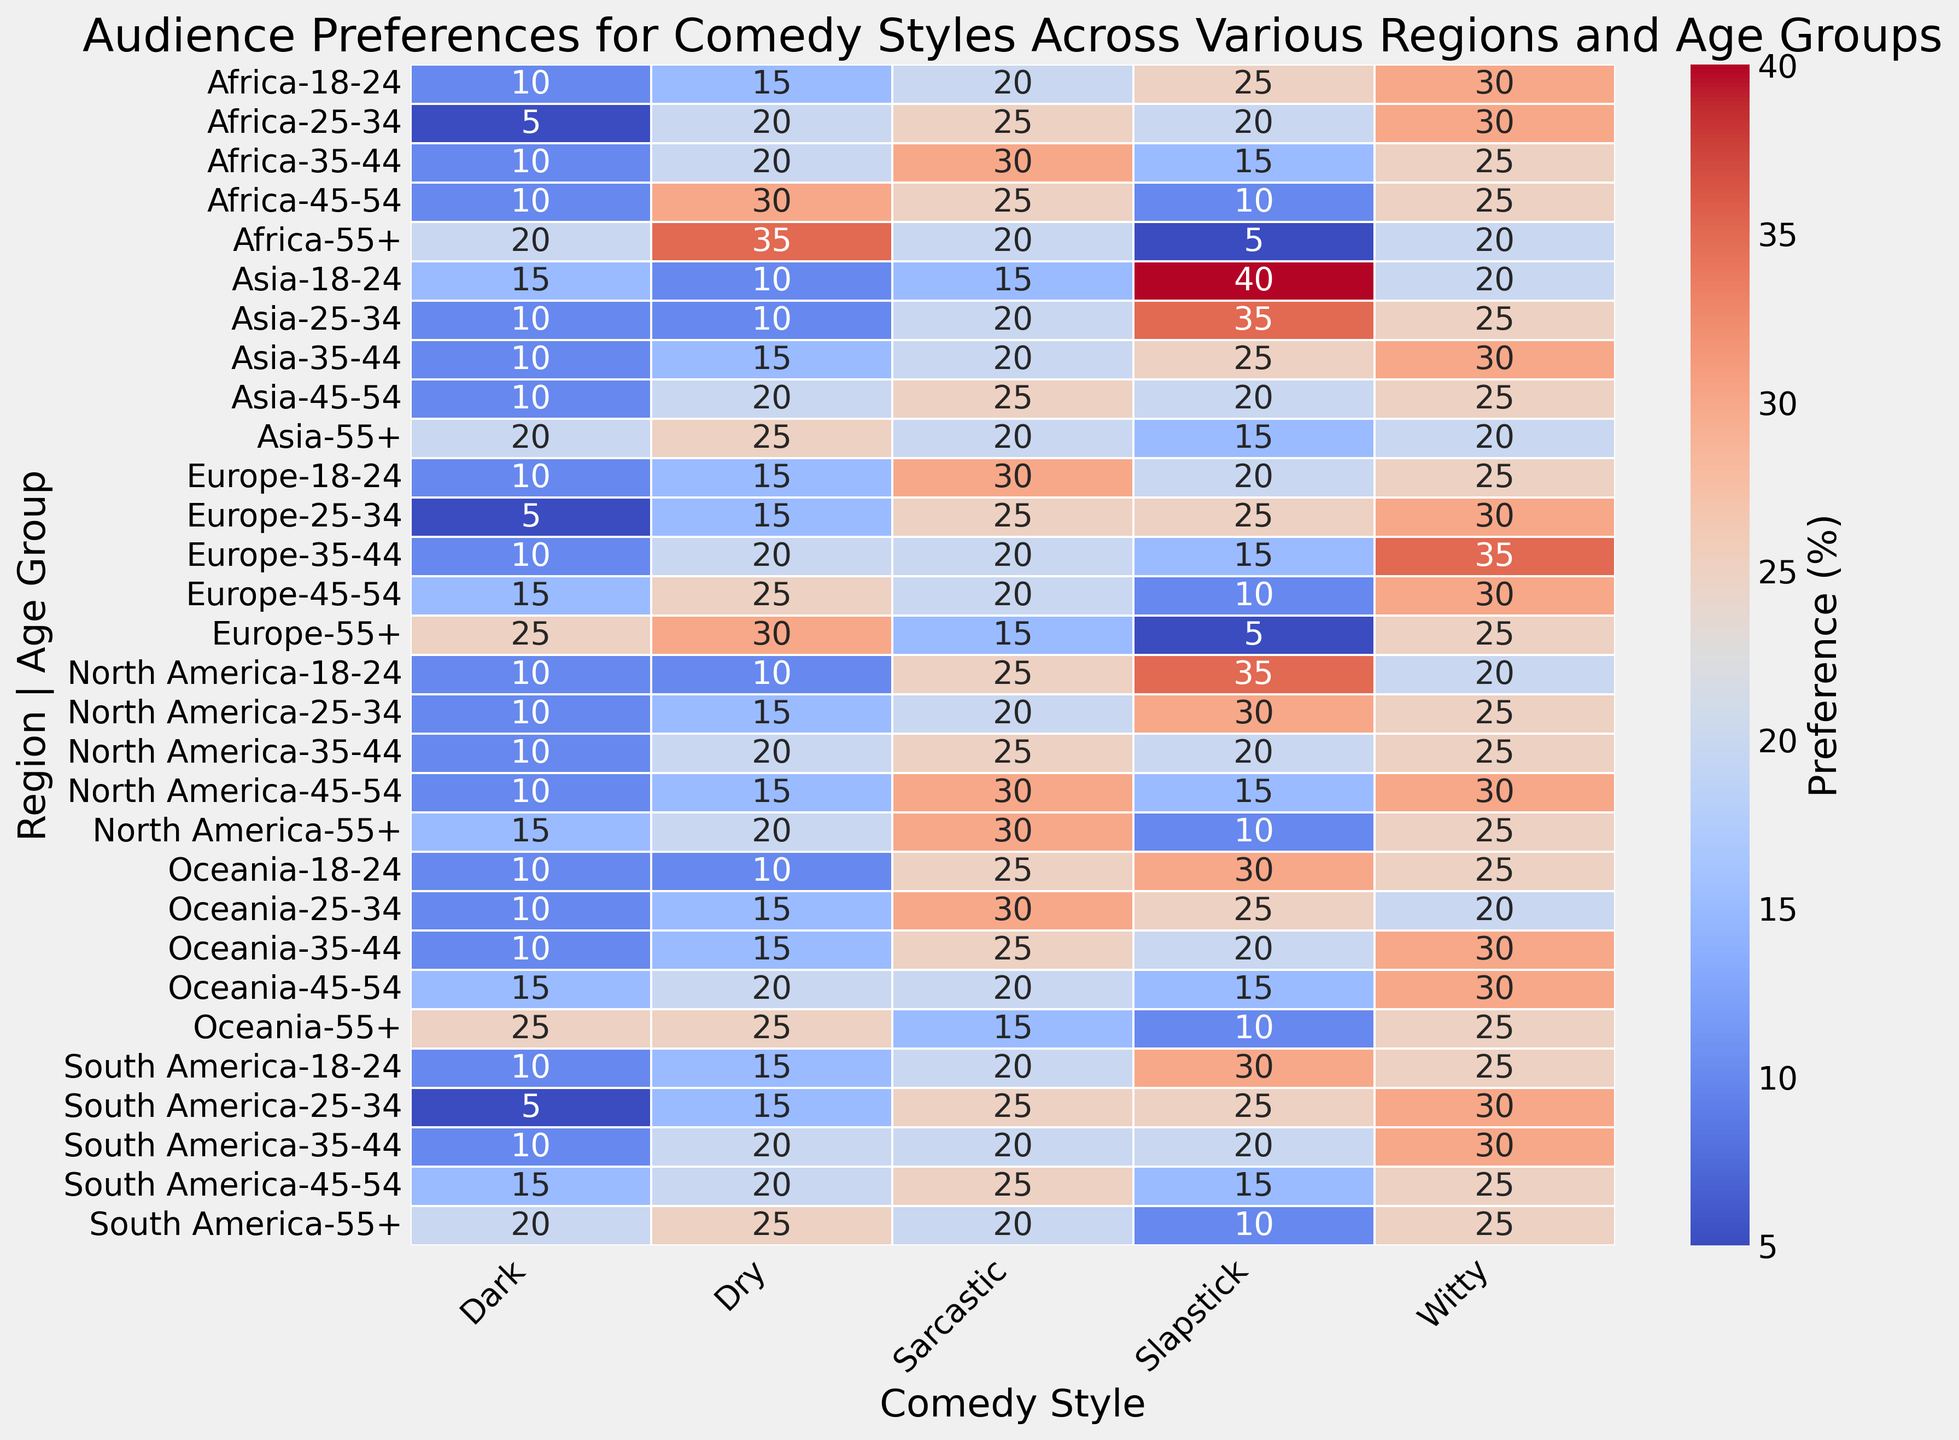Which region and age group prefers slapstick comedy the most? By observing the heatmap, scan for the cell with the highest percentage in the 'Slapstick' column and check the corresponding region and age group.
Answer: Asia, 18-24 Which comedy style is least preferred by the 55+ age group in Europe? Look at the row for Europe, 55+ group and identify the cell with the smallest value across all comedy styles.
Answer: Slapstick Compare the preference for witty comedy between North America (18-24) and Africa (18-24). Which group prefers witty comedy more, and by how much? Locate the cells for witty comedy in North America, 18-24 (value: 20) and Africa, 18-24 (value: 30). Subtract the smaller value from the larger one to find the difference.
Answer: Africa, by 10% What is the average preference for dry comedy in the 25-34 age group across all regions? Extract the percentages for dry comedy in the 25-34 age group for all regions: (North America: 15, Europe: 15, Asia: 10, South America: 15, Africa: 20, Oceania: 15). Calculate the average by summing these values and dividing by the total number of regions. (15 + 15 + 10 + 15 + 20 + 15) / 6 = 15
Answer: 15 How does the preference for dark comedy change with age in South America? Track the values for dark comedy across the age groups in South America: (18-24: 10, 25-34: 5, 35-44: 10, 45-54: 15, 55+: 20). Note the increasing or decreasing trend. The values increase from 10 in the 18-24 group to 20 in the 55+ group.
Answer: It increases Which combination of region and age group has the least total preference for all comedy styles combined? Sum the percentages across all comedy styles for each region and age group. Identify the combination with the smallest sum. For example, Africa, 55+: (5 + 20 + 20 + 35 + 20) = 100.
Answer: Europe, 55+ Based on the visual qualities, which region and age group has the darkest shade in the sarcastic comedy column and what does this signify? The darkest shade indicates the highest value in the sarcastic comedy column. Locate the deepest red shade in the sarcastic column and identify the associated region and age group.
Answer: North America, 55+ signifies 30% preference Calculate the total preference for all comedy styles for the 45-54 age group in Oceania. Add the percentages for all comedy styles for Oceania, 45-54: (15 + 20 + 30 + 20 + 15). (15 + 20 + 30 + 20 + 15) = 100
Answer: 100 In which region do younger audiences (18-24) prefer sarcastic comedy significantly more than older audiences (55+), and by how much? Compare the values of sarcastic comedy for 18-24 and 55+ age groups in each region. Calculate the difference and identify the region where this difference is largest. In North America: (25 - 30) = -5, Europe: (30 - 15) = 15, Asia: (15 - 20) = -5, South America: (20 - 20) = 0, Africa: (20 - 20) = 0, Oceania: (25 - 15) = 10. The largest difference is in Europe.
Answer: Europe, by 15% 